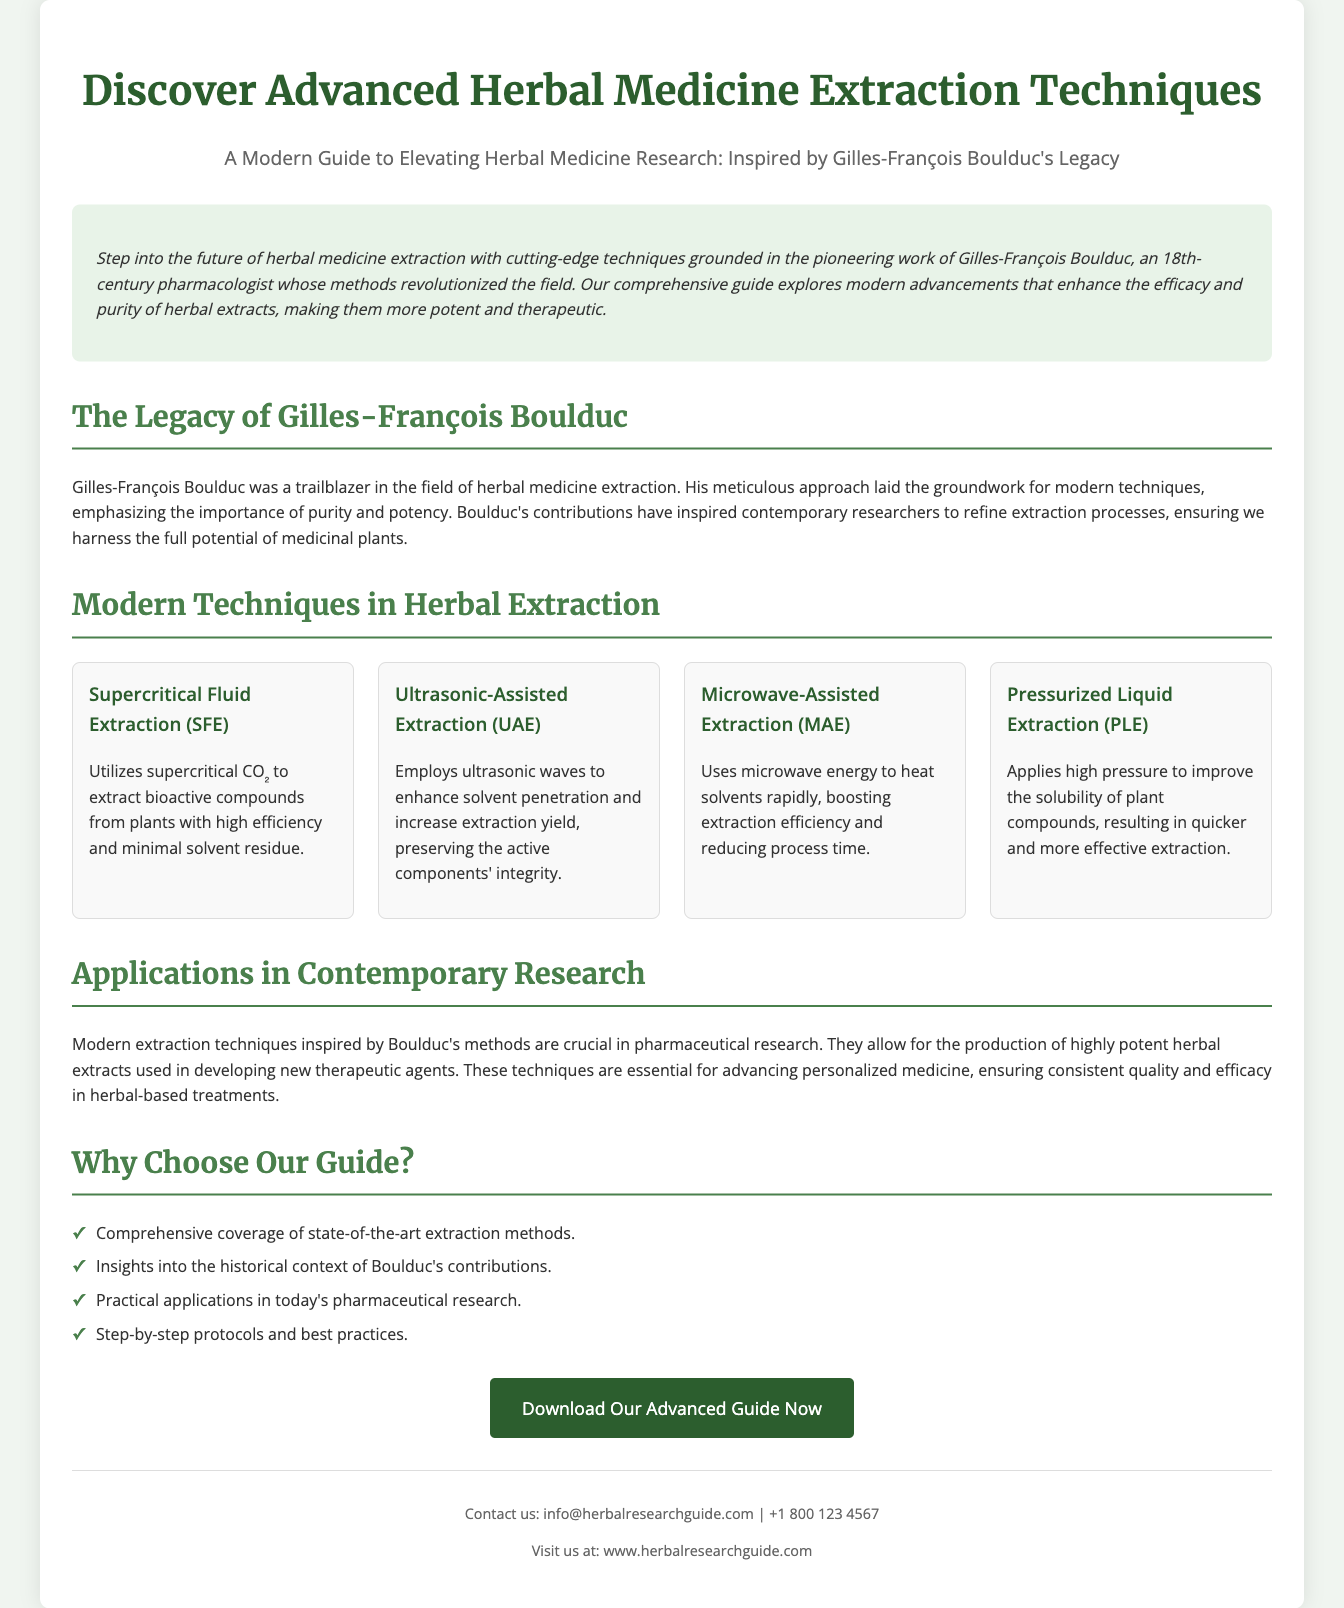what is the title of the document? The title is mentioned at the top of the document in a large font.
Answer: Advanced Herbal Medicine Extraction Techniques who is the historical figure highlighted in the document? The document discusses the contributions of a specific historical figure.
Answer: Gilles-François Boulduc what type of extraction uses supercritical CO₂? This extraction method is listed under modern techniques.
Answer: Supercritical Fluid Extraction (SFE) how many modern extraction techniques are mentioned? The document lists a specific number of techniques in a section dedicated to that topic.
Answer: Four what is one benefit of the guide provided? The document outlines benefits in a specific section.
Answer: Comprehensive coverage of state-of-the-art extraction methods what is the purpose of modern extraction techniques according to the document? The document mentions an application regarding the capability of these techniques in pharmaceutical research.
Answer: Developing new therapeutic agents how can one access the advanced guide? The document includes a specific call to action regarding the guide.
Answer: Download Our Advanced Guide Now what does the introductory paragraph emphasize? The introduction highlights the groundbreaking work related to herbal medicine extraction.
Answer: Pioneering work of Gilles-François Boulduc 